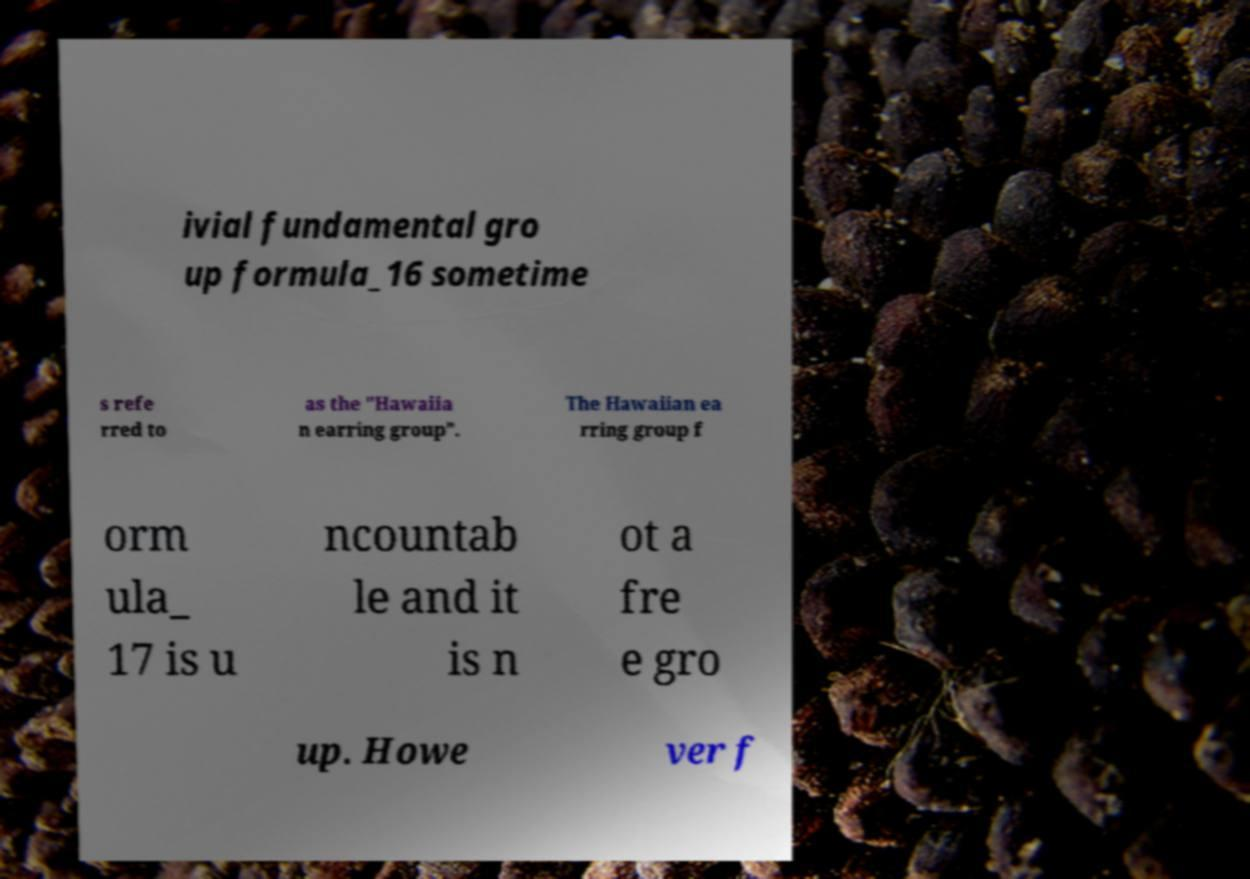There's text embedded in this image that I need extracted. Can you transcribe it verbatim? ivial fundamental gro up formula_16 sometime s refe rred to as the "Hawaiia n earring group". The Hawaiian ea rring group f orm ula_ 17 is u ncountab le and it is n ot a fre e gro up. Howe ver f 